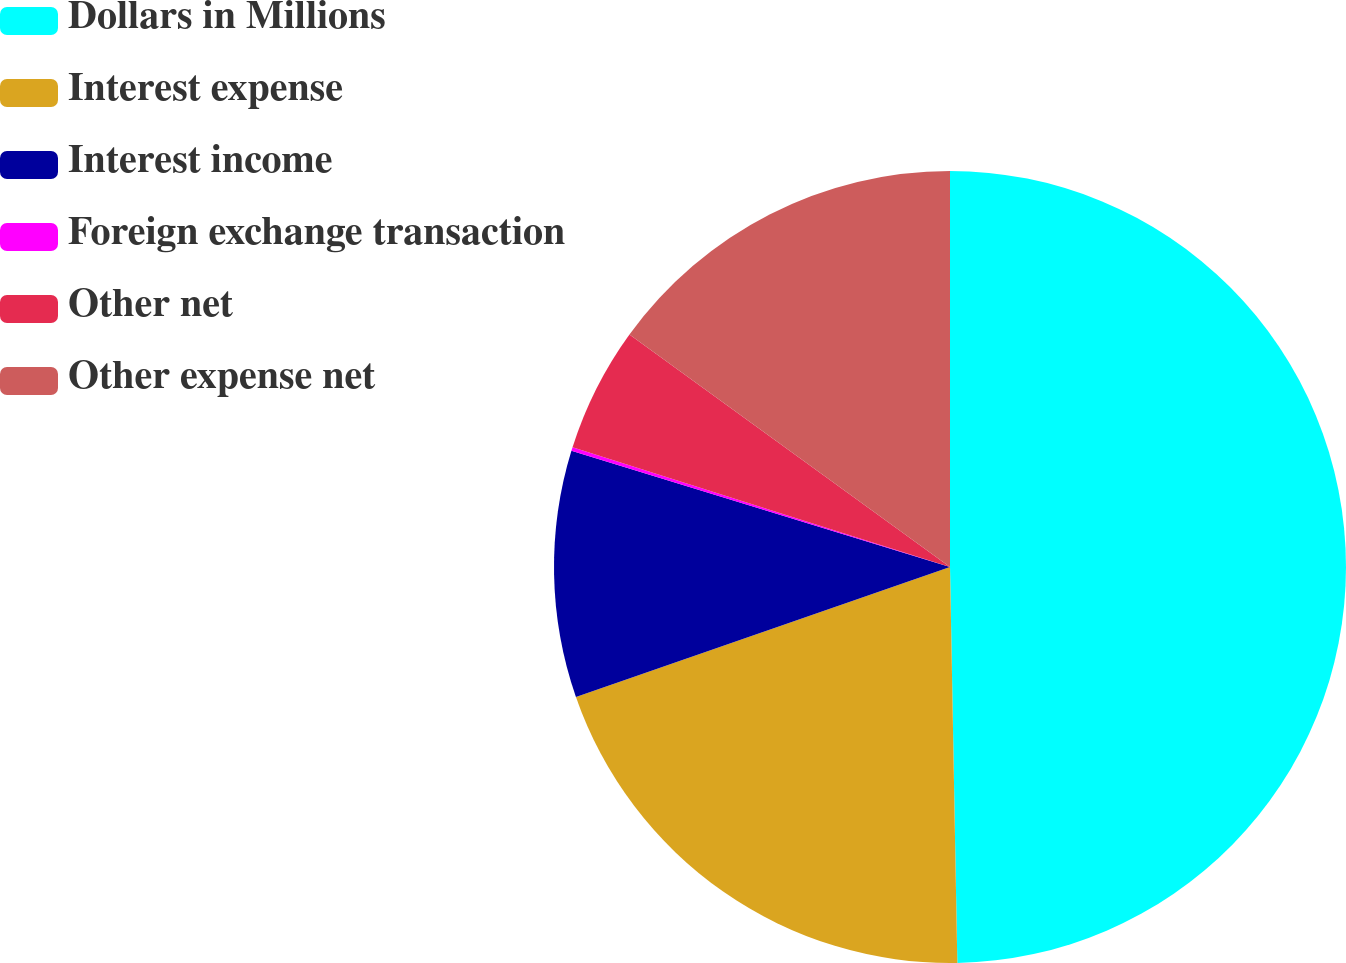<chart> <loc_0><loc_0><loc_500><loc_500><pie_chart><fcel>Dollars in Millions<fcel>Interest expense<fcel>Interest income<fcel>Foreign exchange transaction<fcel>Other net<fcel>Other expense net<nl><fcel>49.7%<fcel>19.97%<fcel>10.06%<fcel>0.15%<fcel>5.1%<fcel>15.01%<nl></chart> 